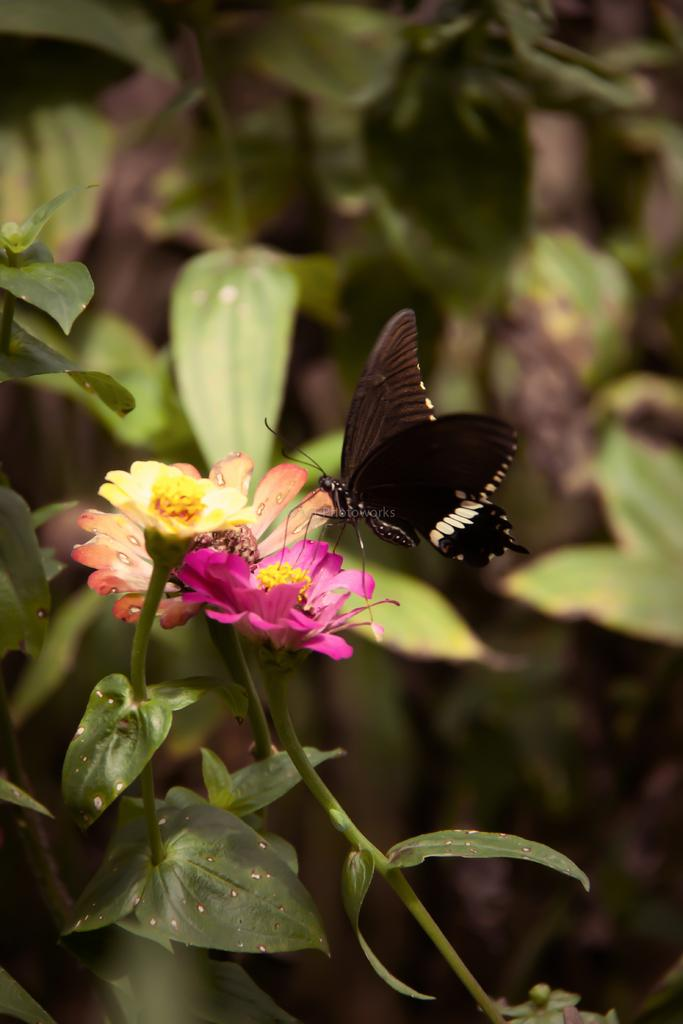What is the main subject of the image? There is a butterfly in the image. Where is the butterfly located in the image? The butterfly is sitting on a flower. What is the flower attached to in the image? The flower is on a plant. What color is the sweater worn by the butterfly in the image? There is no sweater worn by the butterfly in the image, as butterflies do not wear clothing. 